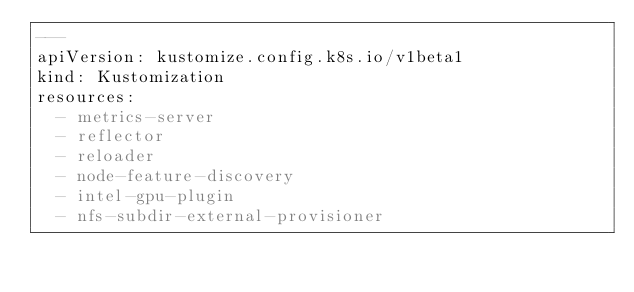Convert code to text. <code><loc_0><loc_0><loc_500><loc_500><_YAML_>---
apiVersion: kustomize.config.k8s.io/v1beta1
kind: Kustomization
resources:
  - metrics-server
  - reflector
  - reloader
  - node-feature-discovery
  - intel-gpu-plugin
  - nfs-subdir-external-provisioner
</code> 